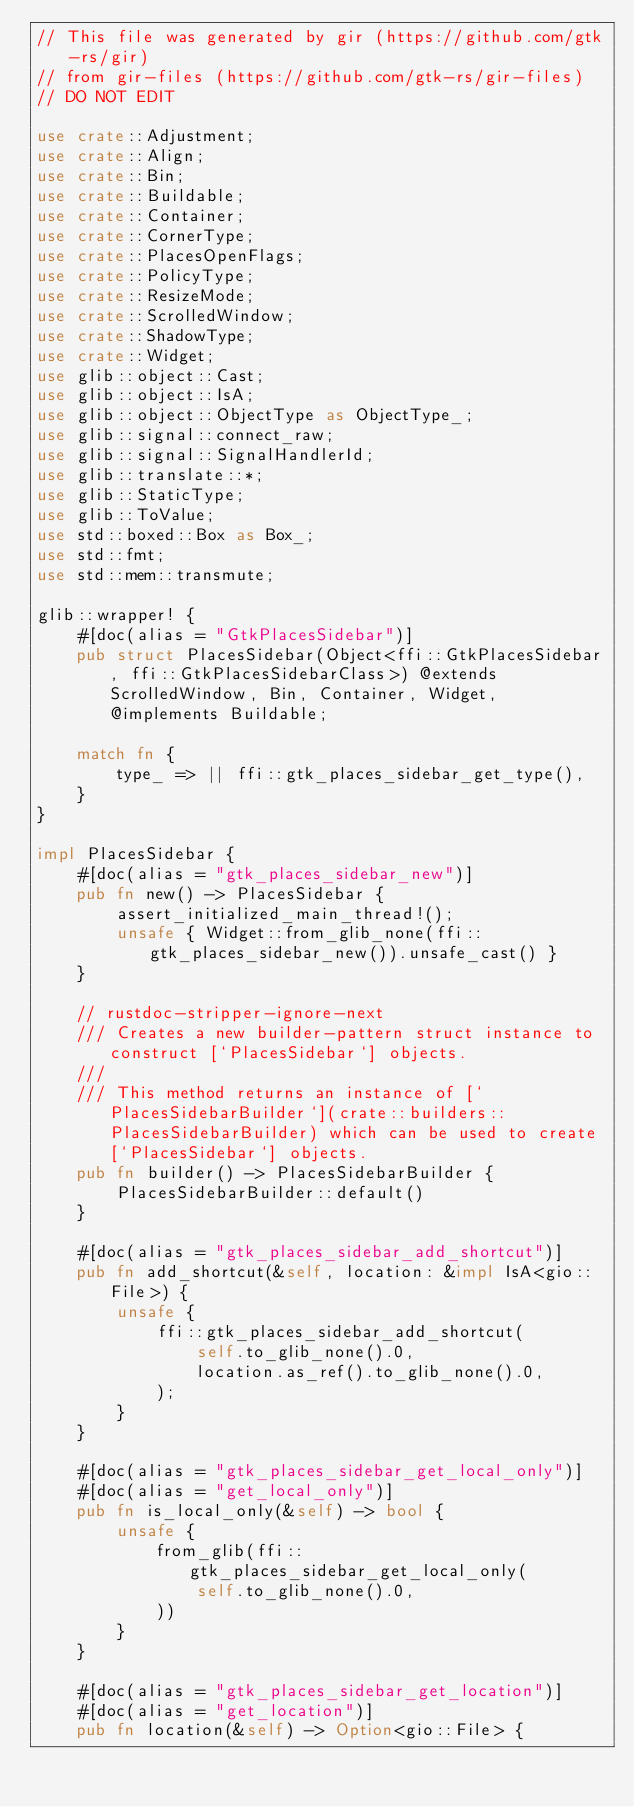<code> <loc_0><loc_0><loc_500><loc_500><_Rust_>// This file was generated by gir (https://github.com/gtk-rs/gir)
// from gir-files (https://github.com/gtk-rs/gir-files)
// DO NOT EDIT

use crate::Adjustment;
use crate::Align;
use crate::Bin;
use crate::Buildable;
use crate::Container;
use crate::CornerType;
use crate::PlacesOpenFlags;
use crate::PolicyType;
use crate::ResizeMode;
use crate::ScrolledWindow;
use crate::ShadowType;
use crate::Widget;
use glib::object::Cast;
use glib::object::IsA;
use glib::object::ObjectType as ObjectType_;
use glib::signal::connect_raw;
use glib::signal::SignalHandlerId;
use glib::translate::*;
use glib::StaticType;
use glib::ToValue;
use std::boxed::Box as Box_;
use std::fmt;
use std::mem::transmute;

glib::wrapper! {
    #[doc(alias = "GtkPlacesSidebar")]
    pub struct PlacesSidebar(Object<ffi::GtkPlacesSidebar, ffi::GtkPlacesSidebarClass>) @extends ScrolledWindow, Bin, Container, Widget, @implements Buildable;

    match fn {
        type_ => || ffi::gtk_places_sidebar_get_type(),
    }
}

impl PlacesSidebar {
    #[doc(alias = "gtk_places_sidebar_new")]
    pub fn new() -> PlacesSidebar {
        assert_initialized_main_thread!();
        unsafe { Widget::from_glib_none(ffi::gtk_places_sidebar_new()).unsafe_cast() }
    }

    // rustdoc-stripper-ignore-next
    /// Creates a new builder-pattern struct instance to construct [`PlacesSidebar`] objects.
    ///
    /// This method returns an instance of [`PlacesSidebarBuilder`](crate::builders::PlacesSidebarBuilder) which can be used to create [`PlacesSidebar`] objects.
    pub fn builder() -> PlacesSidebarBuilder {
        PlacesSidebarBuilder::default()
    }

    #[doc(alias = "gtk_places_sidebar_add_shortcut")]
    pub fn add_shortcut(&self, location: &impl IsA<gio::File>) {
        unsafe {
            ffi::gtk_places_sidebar_add_shortcut(
                self.to_glib_none().0,
                location.as_ref().to_glib_none().0,
            );
        }
    }

    #[doc(alias = "gtk_places_sidebar_get_local_only")]
    #[doc(alias = "get_local_only")]
    pub fn is_local_only(&self) -> bool {
        unsafe {
            from_glib(ffi::gtk_places_sidebar_get_local_only(
                self.to_glib_none().0,
            ))
        }
    }

    #[doc(alias = "gtk_places_sidebar_get_location")]
    #[doc(alias = "get_location")]
    pub fn location(&self) -> Option<gio::File> {</code> 